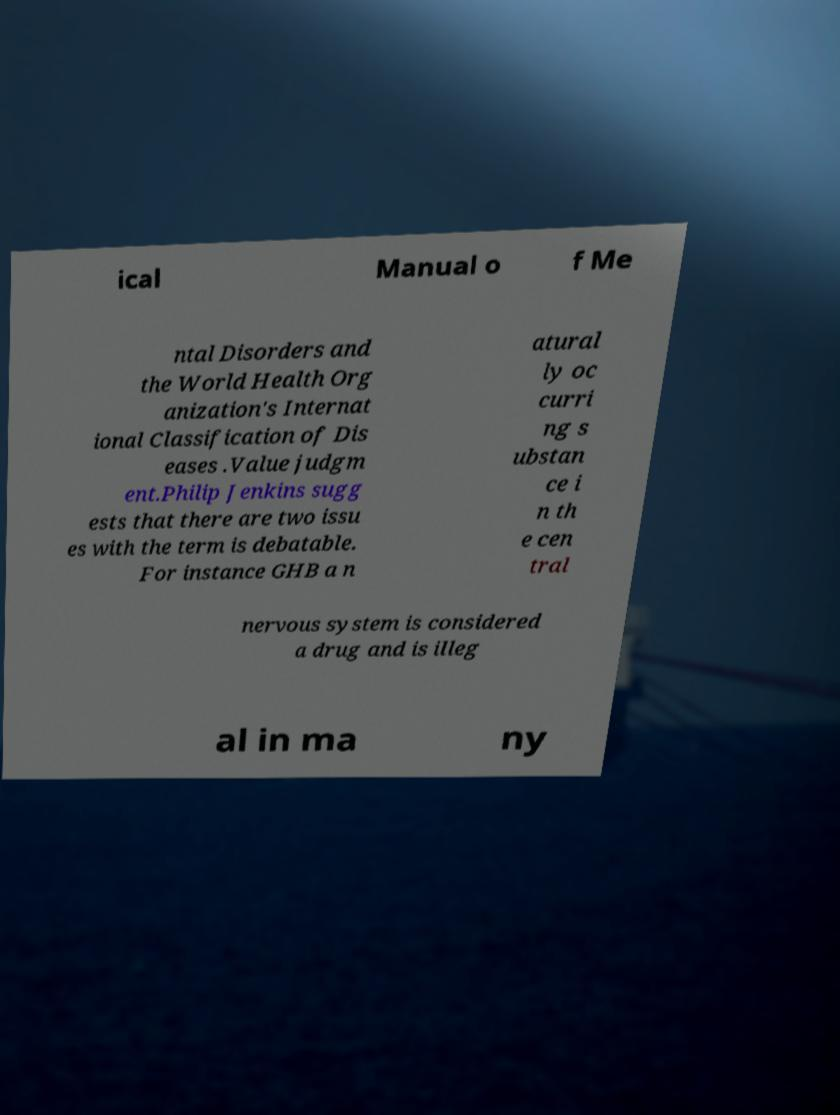For documentation purposes, I need the text within this image transcribed. Could you provide that? ical Manual o f Me ntal Disorders and the World Health Org anization's Internat ional Classification of Dis eases .Value judgm ent.Philip Jenkins sugg ests that there are two issu es with the term is debatable. For instance GHB a n atural ly oc curri ng s ubstan ce i n th e cen tral nervous system is considered a drug and is illeg al in ma ny 